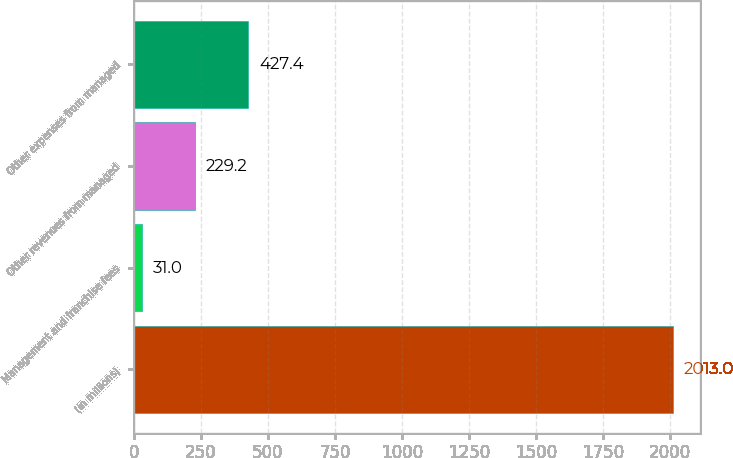<chart> <loc_0><loc_0><loc_500><loc_500><bar_chart><fcel>(in millions)<fcel>Management and franchise fees<fcel>Other revenues from managed<fcel>Other expenses from managed<nl><fcel>2013<fcel>31<fcel>229.2<fcel>427.4<nl></chart> 